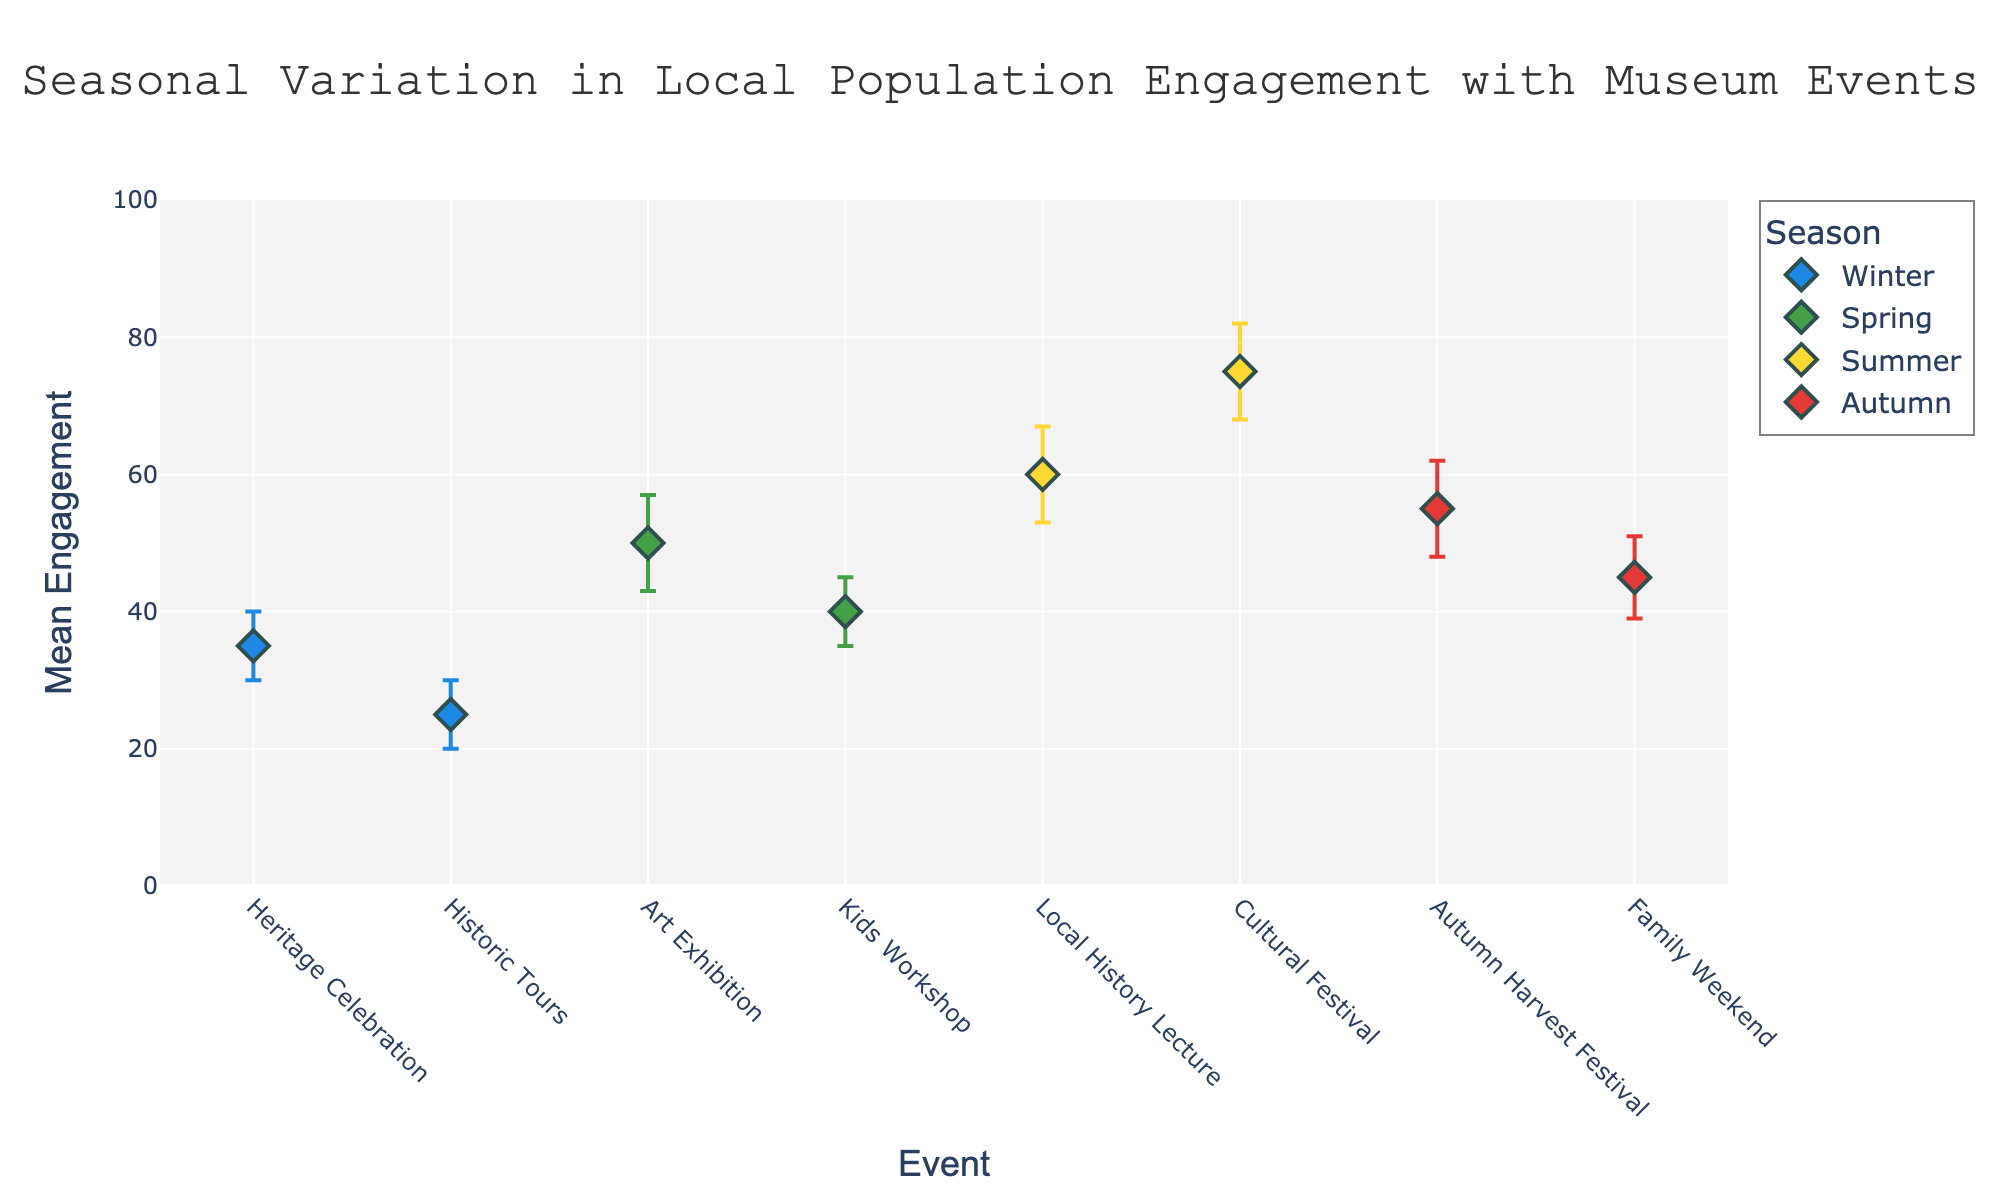How many events are shown for each season? The plot shows multiple markers for events in different seasons. By counting the markers for each season, we find Winter has 2 events, Spring has 2 events, Summer has 2 events, and Autumn has 2 events.
Answer: 2 events per season Which event in Summer has higher engagement? By looking at the markers for Summer, we see "Local History Lecture" and "Cultural Festival." The mean engagement for "Cultural Festival" is 75, higher than the 60 for "Local History Lecture."
Answer: Cultural Festival What is the overall range of mean engagement values? The plot shows mean engagement values ranging from the lowest to the highest. The lowest engagement is for "Historic Tours" in Winter at 25, and the highest is for "Cultural Festival" in Summer at 75. So the range is 25 to 75.
Answer: 25 to 75 Which event has the largest confidence interval? The length of the confidence interval is determined by the vertical lines extending from each marker. "Cultural Festival" in Summer has a confidence interval from 68 to 82, which is the widest.
Answer: Cultural Festival Compare the mean engagement of the "Heritage Celebration" in Winter and the "Art Exhibition" in Spring. Which is higher and by how much? "Heritage Celebration" in Winter has a mean engagement of 35, and "Art Exhibition" in Spring has 50. The difference is 50 - 35, so "Art Exhibition" is higher by 15.
Answer: Art Exhibition by 15 Which season has the highest average mean engagement across its events? We calculate the average mean engagement for each season:
- Winter: (35 + 25) / 2 = 30
- Spring: (50 + 40) / 2 = 45
- Summer: (60 + 75) / 2 = 67.5
- Autumn: (55 + 45) / 2 = 50
Summer has the highest average mean engagement of 67.5.
Answer: Summer Are there any events with overlapping confidence intervals? Checking the plotted error bars, the confidence intervals for "Art Exhibition" and "Kids Workshop" in Spring overlap slightly around 43 and 45.
Answer: Yes, in Spring What is the difference in mean engagement between the highest and lowest engaged events? The highest mean engagement is "Cultural Festival" at 75, and the lowest is "Historic Tours" at 25. The difference is 75 - 25.
Answer: 50 What is the average mean engagement of all events combined? By summing all mean engagement values: 35 + 25 + 50 + 40 + 60 + 75 + 55 + 45 = 385. There are 8 events, so the average is 385 / 8.
Answer: 48.125 Is there any season where all events have the mean engagement above 50? Winter (35, 25), Spring (50, 40), Summer (60, 75), Autumn (55, 45). Only Summer has all events with mean engagement above 50.
Answer: Yes, Summer 